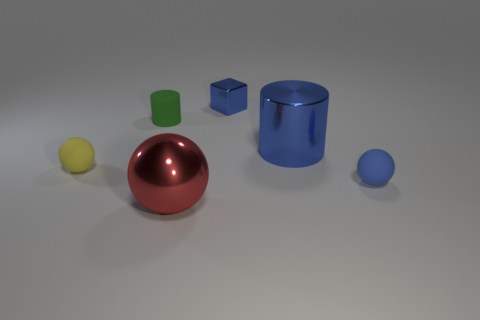Are there any other things that are the same shape as the small metallic object? Yes, the small blue cube shares the same shape as the larger green cube in the image. They both have the same cube geometry, although they differ in size and color. 